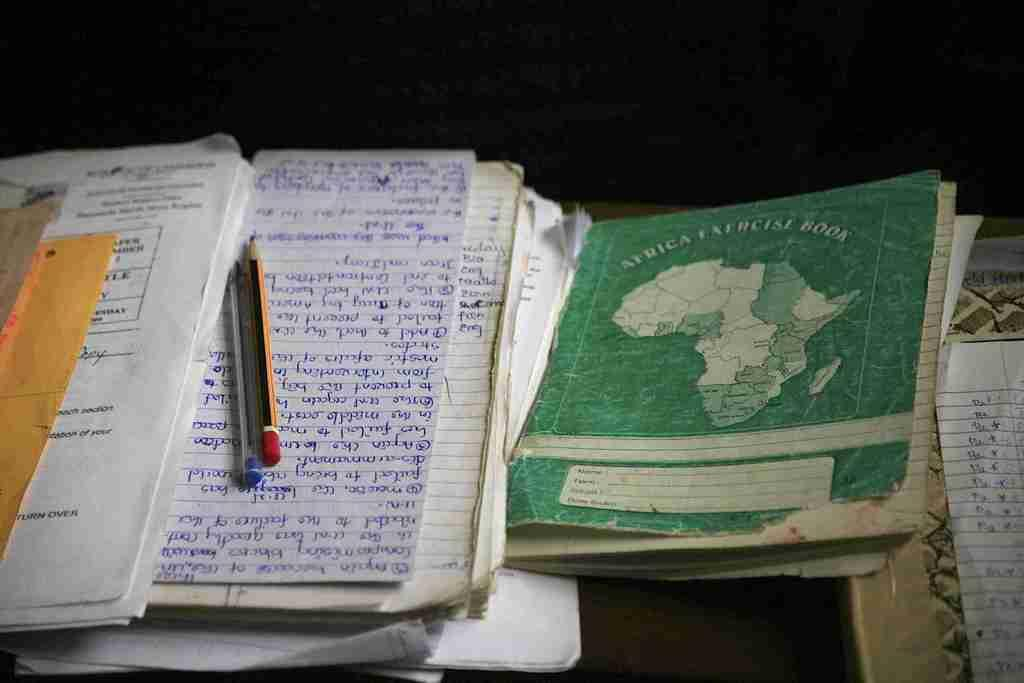<image>
Write a terse but informative summary of the picture. Several books with writing including one that says AFRICA EXERCISE BOOK. 